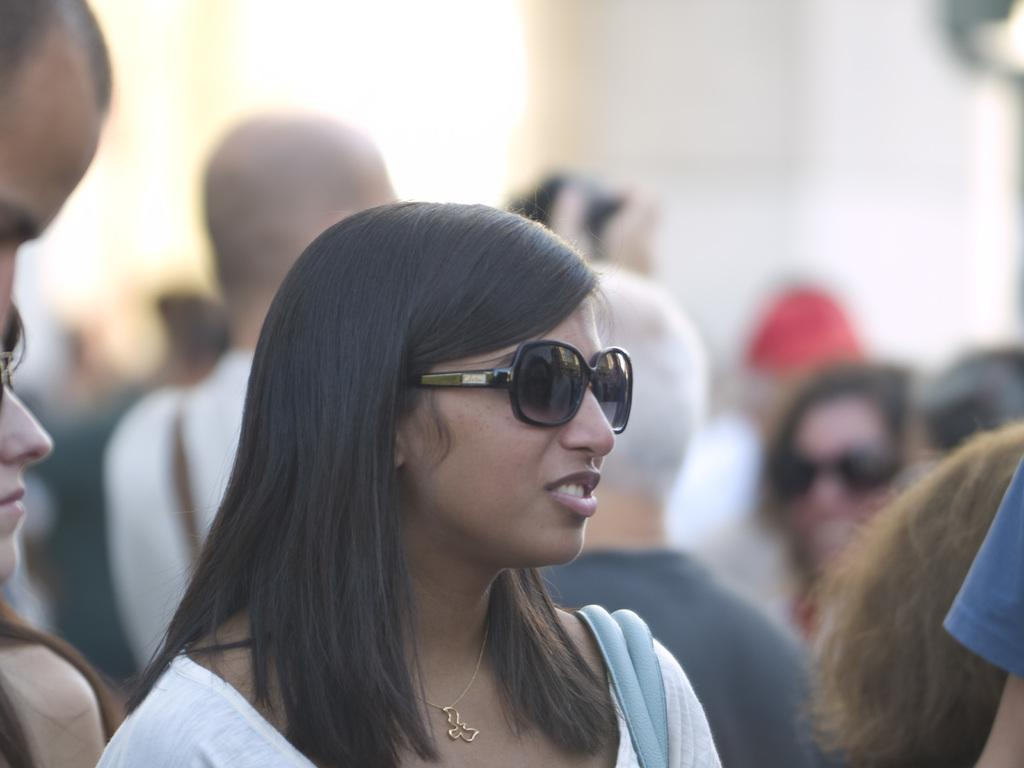Who is the main subject in the image? There is a woman in the image. What is the woman wearing on her face? The woman is wearing goggles. Are there any other people in the image? Yes, there are people standing in the image. Can you describe the background of the image? The background of the image appears blurry. What type of minute is visible in the image? There is no mention of a minute in the image, as it features a woman wearing goggles and other people standing nearby. 